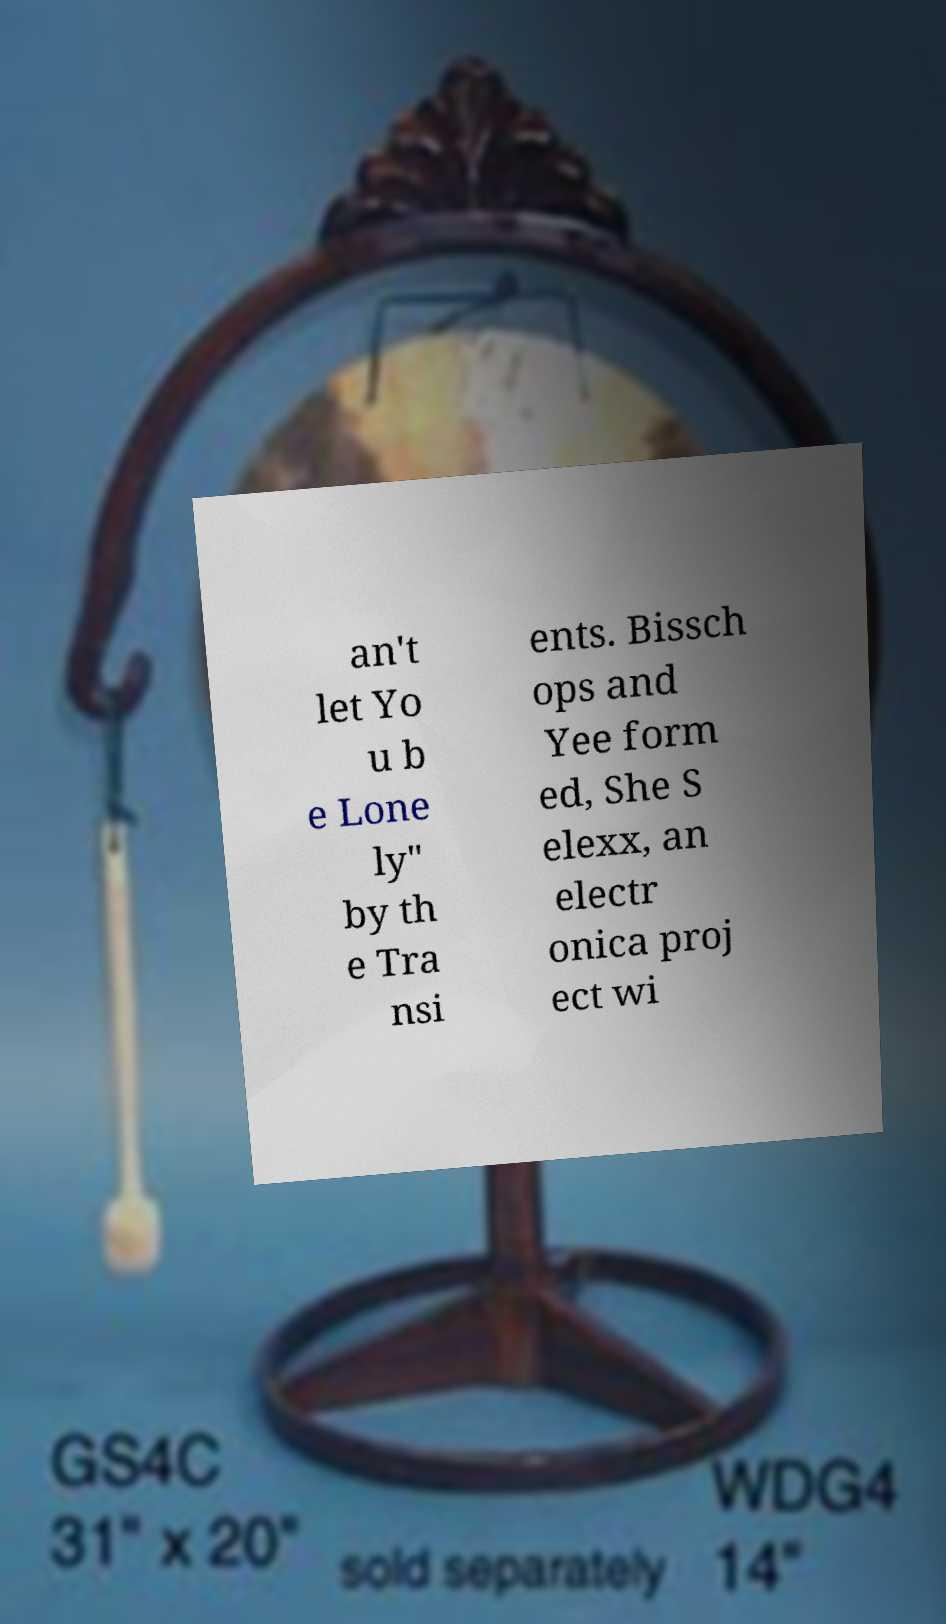For documentation purposes, I need the text within this image transcribed. Could you provide that? an't let Yo u b e Lone ly" by th e Tra nsi ents. Bissch ops and Yee form ed, She S elexx, an electr onica proj ect wi 